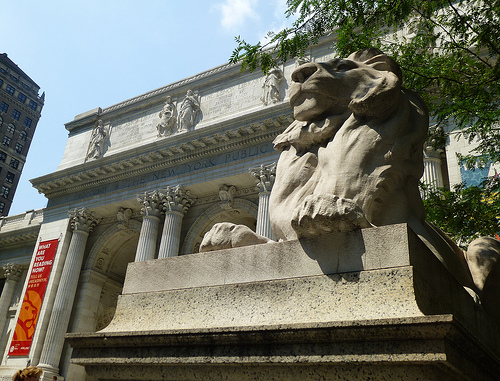<image>
Can you confirm if the statue is under the arch? Yes. The statue is positioned underneath the arch, with the arch above it in the vertical space. 